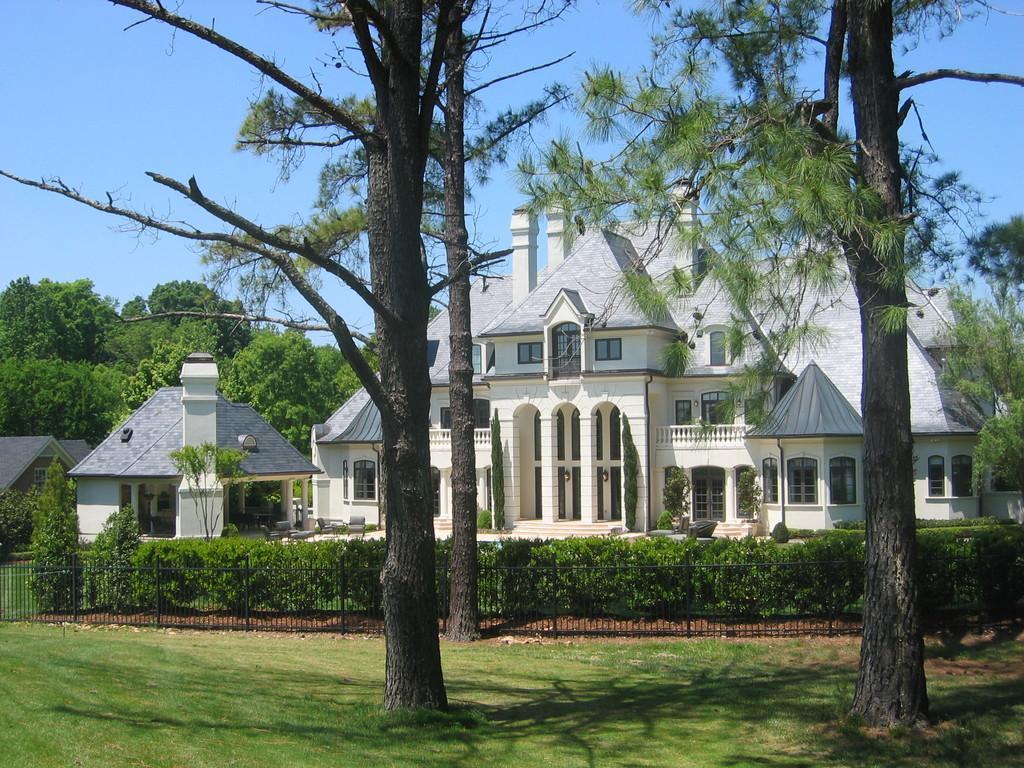Could you give a brief overview of what you see in this image? In this picture I can see buildings, trees and I can see plants and a metal fence and I can see grass on the ground and a blue sky 